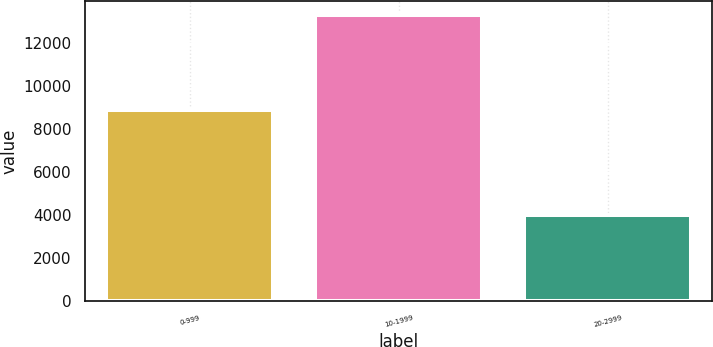Convert chart. <chart><loc_0><loc_0><loc_500><loc_500><bar_chart><fcel>0-999<fcel>10-1999<fcel>20-2999<nl><fcel>8905<fcel>13289<fcel>4010<nl></chart> 